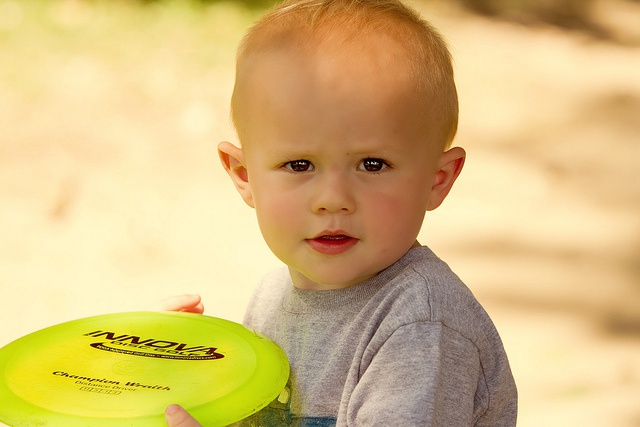Describe the objects in this image and their specific colors. I can see people in khaki, tan, brown, gray, and darkgray tones and frisbee in khaki, yellow, and olive tones in this image. 